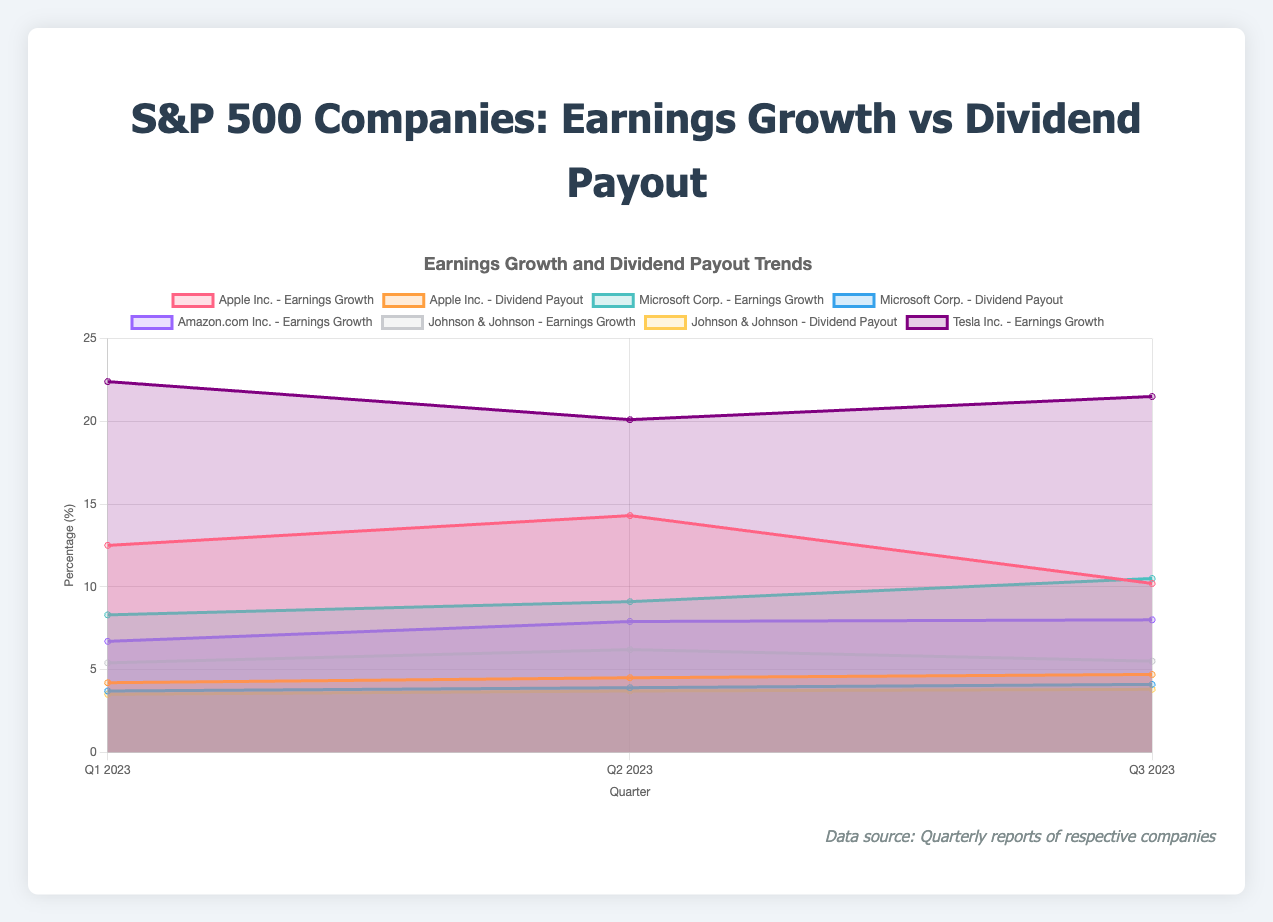what is the title of the chart? The title of the chart is displayed at the top and is usually a brief, descriptive statement about the chart's content. In this instance, the chart title is "S&P 500 Companies: Earnings Growth vs Dividend Payout".
Answer: S&P 500 Companies: Earnings Growth vs Dividend Payout Which company shows the highest earnings growth in Q1 2023? To determine the company with the highest earnings growth in Q1 2023, look for the highest value on the y-axis under the Q1 2023 label. Tesla Inc. has the highest earnings growth at 22.4%.
Answer: Tesla Inc How does Apple Inc.'s earnings growth change from Q1 to Q3 2023? To find this, observe the data points for Apple Inc. in Q1, Q2, and Q3 2023. The values are 12.5%, 14.3%, and 10.2% respectively. The earnings growth increases from Q1 to Q2 and then decreases from Q2 to Q3.
Answer: Increases from Q1 to Q2, decreases from Q2 to Q3 What is the range of Microsoft's dividend payouts from Q1 to Q3 2023? The range is calculated as the difference between the highest and lowest values in the given period. For Microsoft, the dividend payouts are 3.7%, 3.9%, and 4.1%. The range is 4.1% - 3.7% = 0.4%.
Answer: 0.4% Which company consistently pays the highest dividends across all quarters? Examining the colored areas representing dividend payouts for each company in all quarters, the values for Apple Inc. are the highest at 4.2%, 4.5%, and 4.7% compared to other companies.
Answer: Apple Inc How do the earnings growth patterns compare between Amazon.com Inc. and Johnson & Johnson across the three quarters? Compare the earnings growth data for the two companies: Amazon (6.7%, 7.9%, 8.0%) and Johnson & Johnson (5.4%, 6.2%, 5.5%). Amazon.com Inc. shows an upward trend, while Johnson & Johnson has fluctuating growth.
Answer: Amazon.com Inc. shows an upward trend; Johnson & Johnson's growth fluctuates What is the average earnings growth of Tesla Inc. in 2023? Tesla Inc.'s earnings growth values for Q1, Q2, and Q3 2023 are 22.4%, 20.1%, and 21.5%. The average is calculated as (22.4 + 20.1 + 21.5) / 3 = 21.33%.
Answer: 21.33% Which company had no dividend payouts, and how can we verify it on the chart? Check the chart for areas where the dividend payout is always at 0%. Amazon.com Inc. and Tesla Inc. have no dividend payouts, visible because there is no shaded area for dividends for these companies.
Answer: Amazon.com Inc., Tesla Inc What trend do we observe in Johnson & Johnson's dividend payouts over the three quarters? Identify the dividend payout values for Johnson & Johnson in Q1, Q2, and Q3 2023. The values are 3.5%, 3.7%, and 3.8%. The trend indicates a slight increase each quarter.
Answer: Slight increase each quarter In which quarter did Apple Inc. have its lowest earnings growth, and what was the value? Examine the data points representing Apple Inc.'s earnings growth in each quarter. The lowest earnings growth occurred in Q3 2023, with a value of 10.2%.
Answer: Q3 2023, 10.2% 